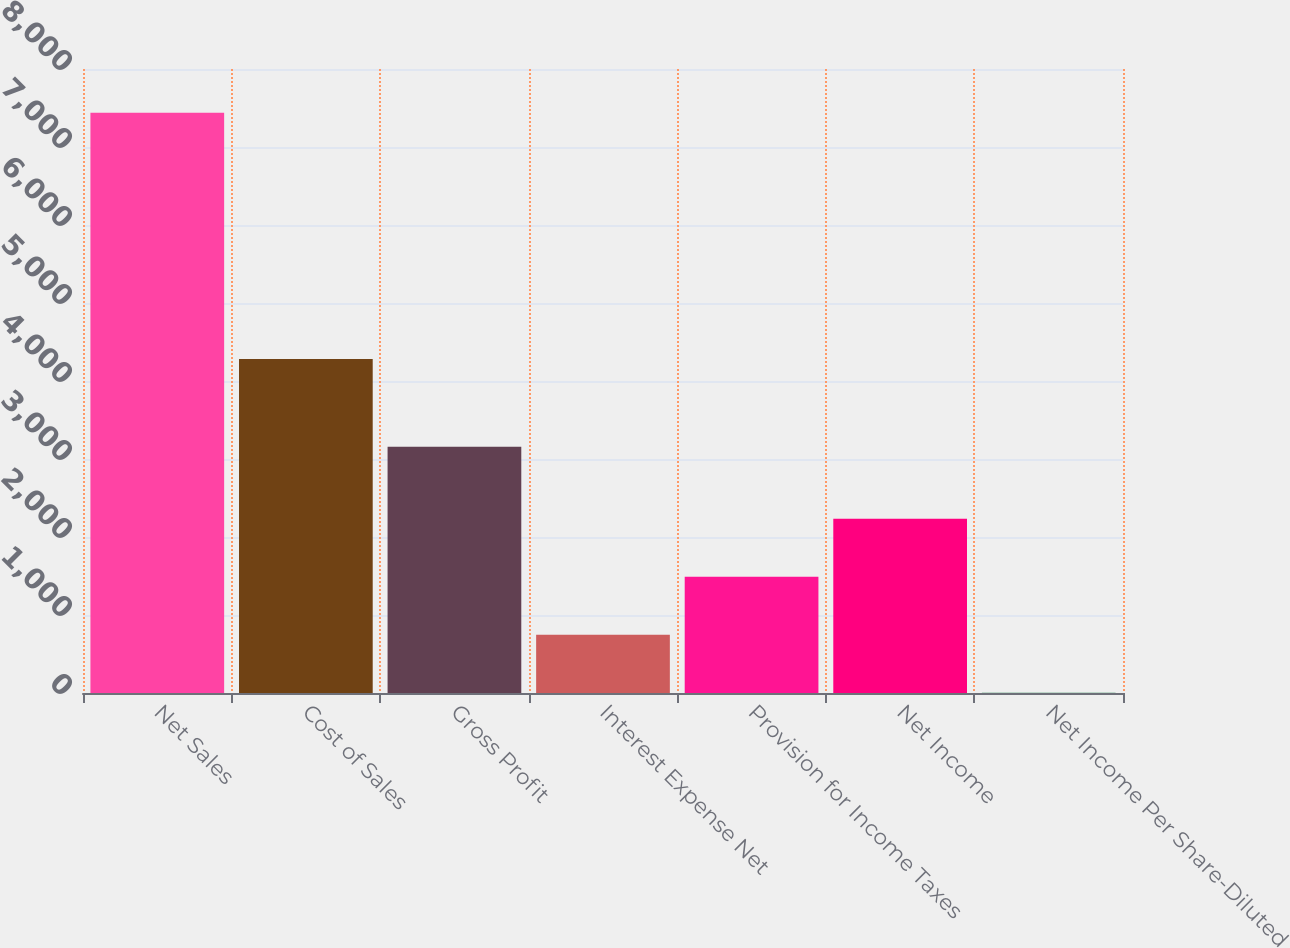<chart> <loc_0><loc_0><loc_500><loc_500><bar_chart><fcel>Net Sales<fcel>Cost of Sales<fcel>Gross Profit<fcel>Interest Expense Net<fcel>Provision for Income Taxes<fcel>Net Income<fcel>Net Income Per Share-Diluted<nl><fcel>7440.2<fcel>4282.3<fcel>3157.9<fcel>747.03<fcel>1490.72<fcel>2234.41<fcel>3.34<nl></chart> 